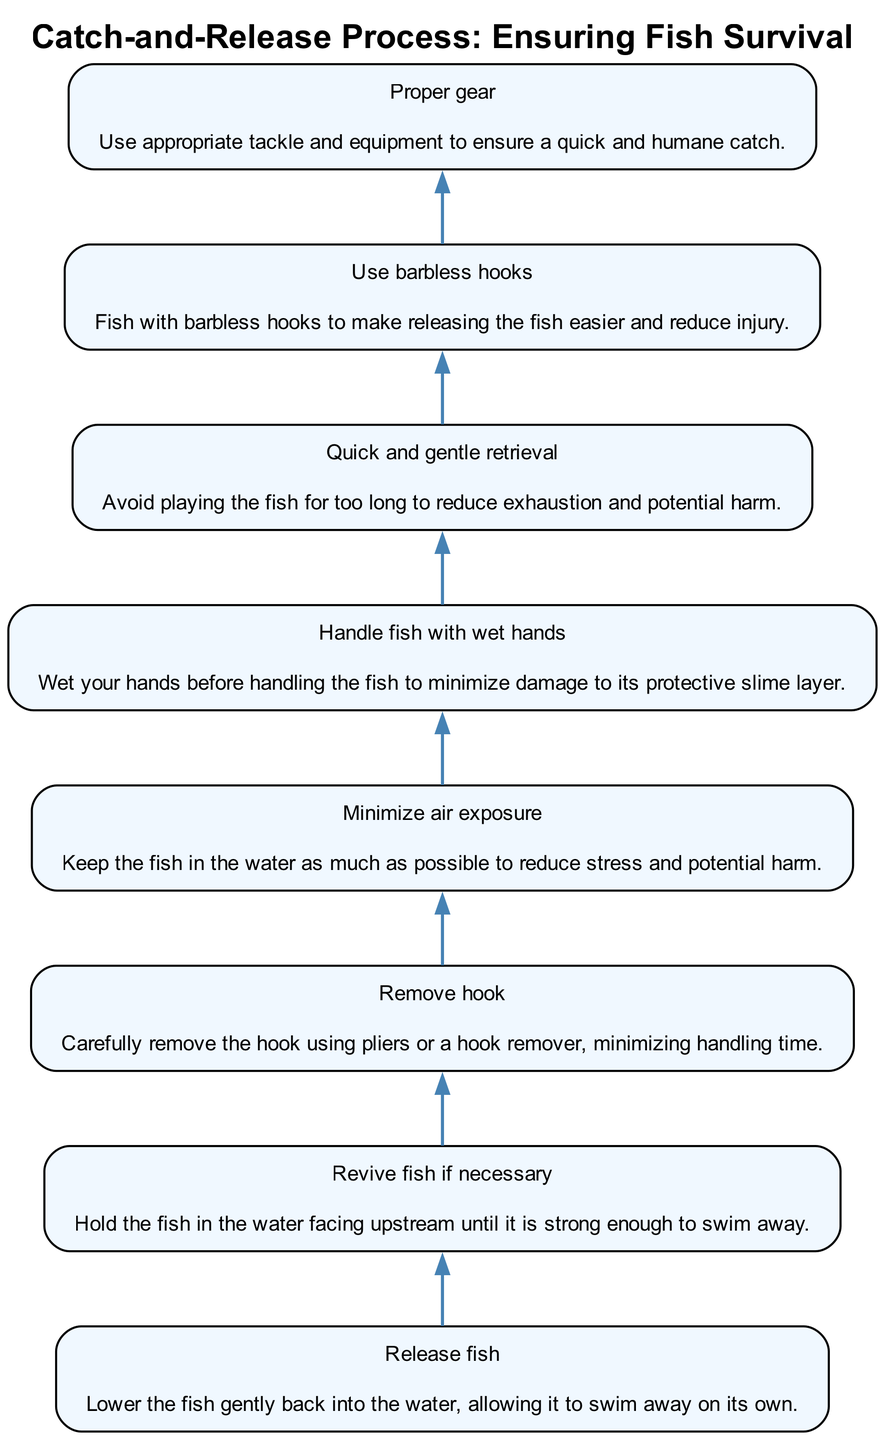What is the first step in the catch-and-release process? The first step listed at the bottom of the diagram is "Release fish," indicating the initial action to take after catching a fish.
Answer: Release fish How many steps are in the diagram? Counting all the elements in the diagram, there are eight steps listed.
Answer: 8 Which step involves minimizing air contact with the fish? The step titled "Minimize air exposure" specifically addresses keeping the fish in water to avoid stress, and it comes before releasing the fish.
Answer: Minimize air exposure What action should you take before handling a fish? According to the diagram, "Handle fish with wet hands" is the recommended action before touching the fish to protect its slime layer.
Answer: Handle fish with wet hands Why is it important to use barbless hooks? The diagram states that using barbless hooks makes it easier to release fish and contributes to reducing injury, which is essential for the fish's survival.
Answer: To reduce injury What is the last step in the process? The last step at the top of the diagram is "Release fish," indicating that the process culminates in allowing the fish to swim away freely.
Answer: Release fish What does the diagram indicate about using appropriate tackle? The step "Proper gear" emphasizes the importance of using suitable tackle to ensure that the fish is caught quickly and humanely.
Answer: Proper gear If a fish appears weak after catching, what action should you take? The diagram advises to "Revive fish if necessary," which entails holding the fish in water facing upstream until it can swim away on its own.
Answer: Revive fish if necessary 